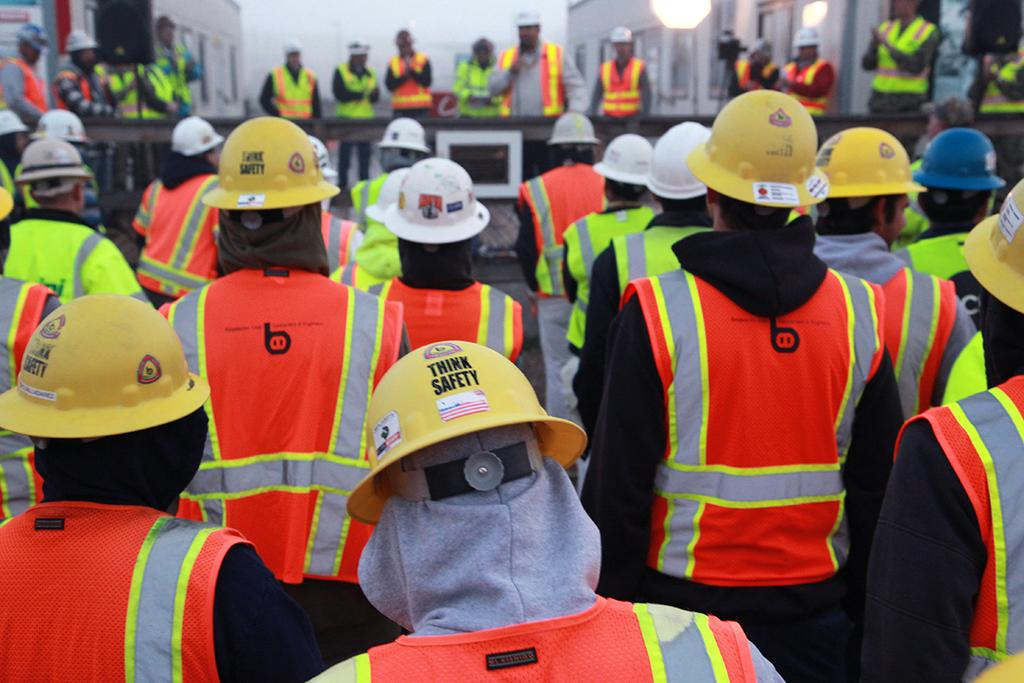What is the person in the image doing? The person is standing and holding a mic. What is the person wearing on their head? The person is wearing a hat. What type of jacket is the person wearing? The person is wearing a high-wiz jacket. What is the person's relationship with the group of people in the image? The person is addressing a group of people. How are the people in the group positioned in relation to the person? The group of people is around the person. What type of pump is visible in the image? There is no pump present in the image. Where is the lunchroom located in the image? The image does not show a lunchroom or any indication of its location. 